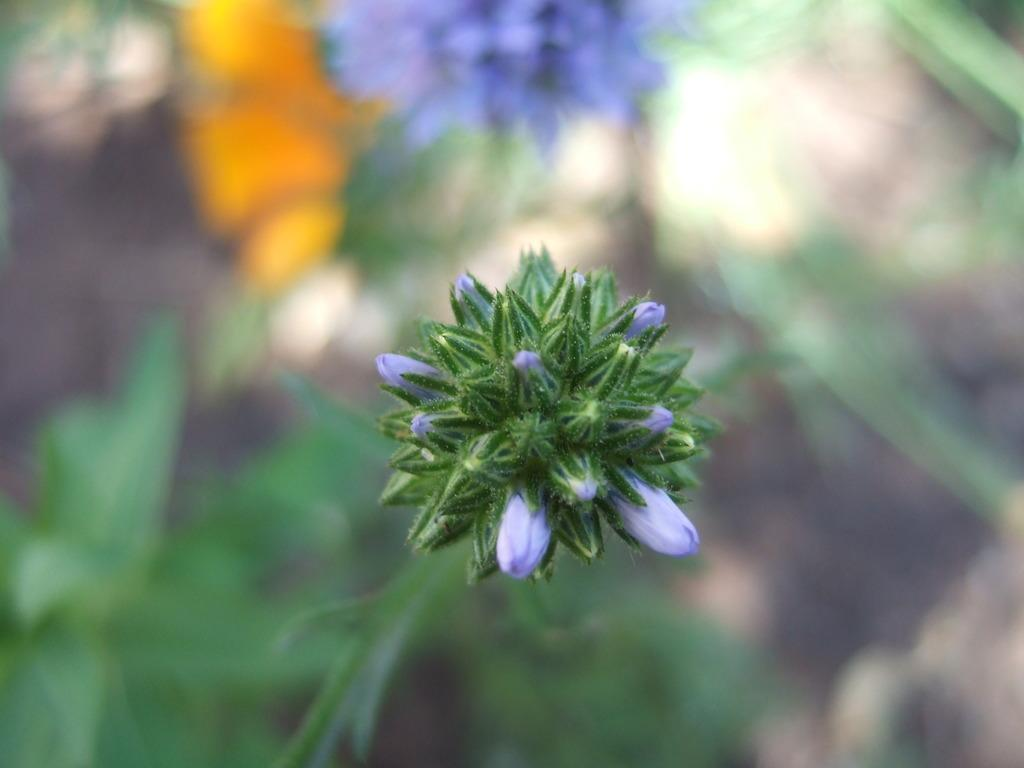What type of plant life is present in the image? There are flower buds in the image. Can you describe the background of the image? The background of the image is blurry. What type of leather is visible in the image? There is no leather present in the image; it only features flower buds and a blurry background. 